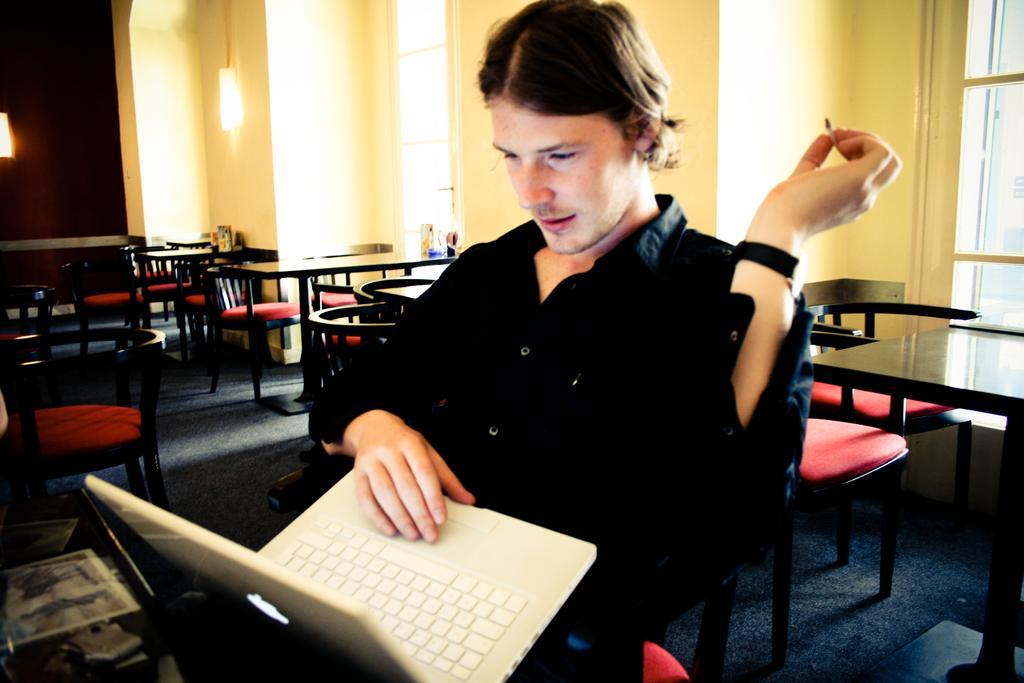In one or two sentences, can you explain what this image depicts? In this image I can see the person wearing the black color dress and holding the laptop. To the side I can see many chairs and tables. In the background I can see the wall, lights and the window. 